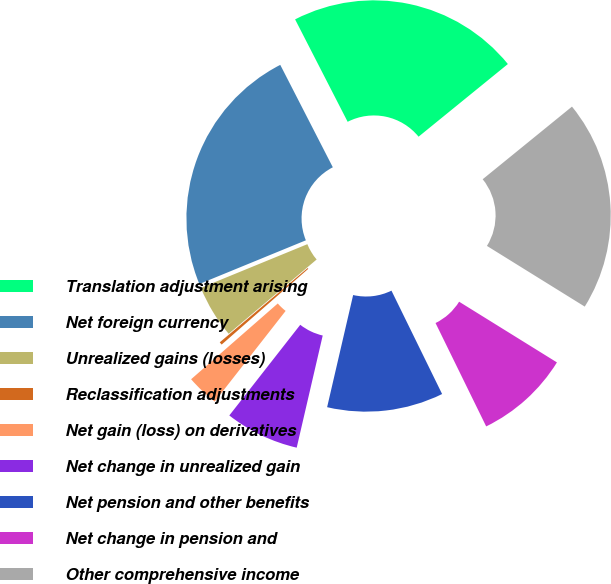Convert chart to OTSL. <chart><loc_0><loc_0><loc_500><loc_500><pie_chart><fcel>Translation adjustment arising<fcel>Net foreign currency<fcel>Unrealized gains (losses)<fcel>Reclassification adjustments<fcel>Net gain (loss) on derivatives<fcel>Net change in unrealized gain<fcel>Net pension and other benefits<fcel>Net change in pension and<fcel>Other comprehensive income<nl><fcel>21.68%<fcel>23.65%<fcel>4.97%<fcel>0.27%<fcel>3.0%<fcel>6.94%<fcel>10.88%<fcel>8.91%<fcel>19.71%<nl></chart> 